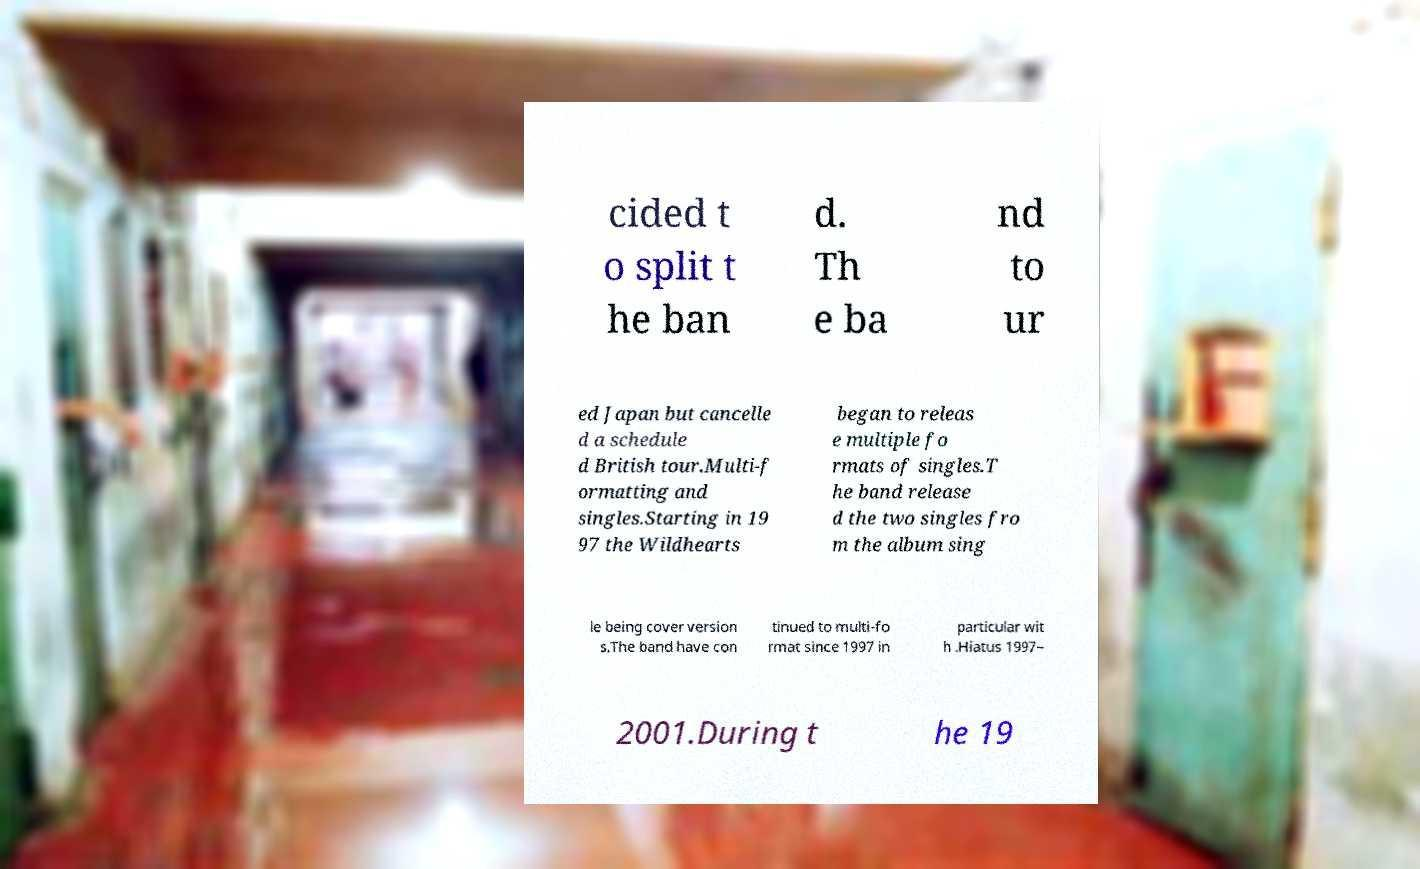For documentation purposes, I need the text within this image transcribed. Could you provide that? cided t o split t he ban d. Th e ba nd to ur ed Japan but cancelle d a schedule d British tour.Multi-f ormatting and singles.Starting in 19 97 the Wildhearts began to releas e multiple fo rmats of singles.T he band release d the two singles fro m the album sing le being cover version s.The band have con tinued to multi-fo rmat since 1997 in particular wit h .Hiatus 1997– 2001.During t he 19 